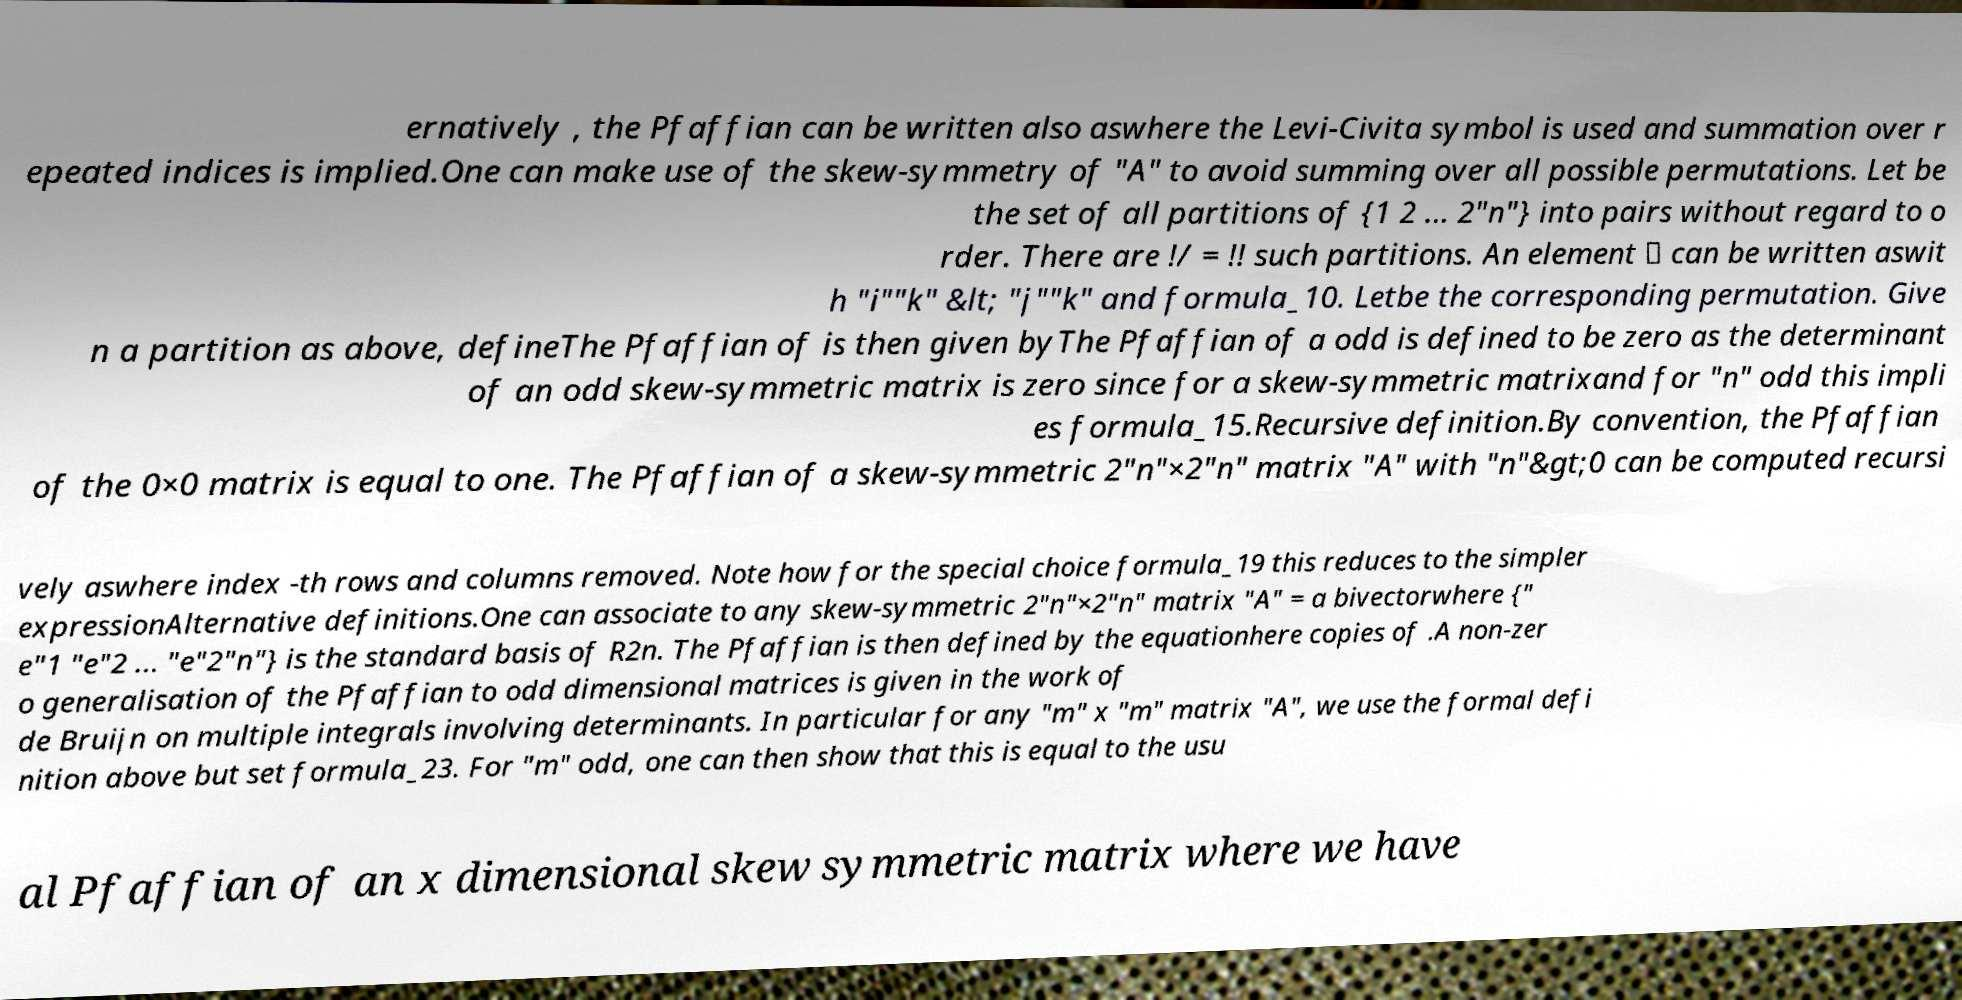I need the written content from this picture converted into text. Can you do that? ernatively , the Pfaffian can be written also aswhere the Levi-Civita symbol is used and summation over r epeated indices is implied.One can make use of the skew-symmetry of "A" to avoid summing over all possible permutations. Let be the set of all partitions of {1 2 ... 2"n"} into pairs without regard to o rder. There are !/ = !! such partitions. An element ∈ can be written aswit h "i""k" &lt; "j""k" and formula_10. Letbe the corresponding permutation. Give n a partition as above, defineThe Pfaffian of is then given byThe Pfaffian of a odd is defined to be zero as the determinant of an odd skew-symmetric matrix is zero since for a skew-symmetric matrixand for "n" odd this impli es formula_15.Recursive definition.By convention, the Pfaffian of the 0×0 matrix is equal to one. The Pfaffian of a skew-symmetric 2"n"×2"n" matrix "A" with "n"&gt;0 can be computed recursi vely aswhere index -th rows and columns removed. Note how for the special choice formula_19 this reduces to the simpler expressionAlternative definitions.One can associate to any skew-symmetric 2"n"×2"n" matrix "A" = a bivectorwhere {" e"1 "e"2 ... "e"2"n"} is the standard basis of R2n. The Pfaffian is then defined by the equationhere copies of .A non-zer o generalisation of the Pfaffian to odd dimensional matrices is given in the work of de Bruijn on multiple integrals involving determinants. In particular for any "m" x "m" matrix "A", we use the formal defi nition above but set formula_23. For "m" odd, one can then show that this is equal to the usu al Pfaffian of an x dimensional skew symmetric matrix where we have 